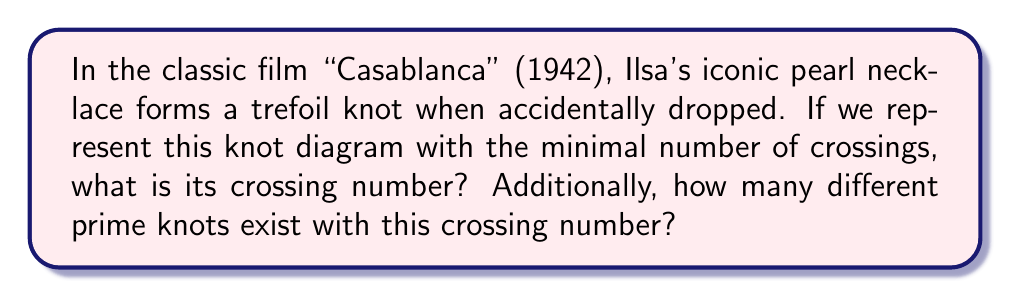What is the answer to this math problem? Let's approach this step-by-step:

1) The trefoil knot is one of the simplest non-trivial knots in knot theory.

2) To determine its crossing number, we need to consider its minimal diagram:

   [asy]
   import geometry;
   
   path p = (0,0){dir(60)}..{dir(-60)}(1,0){dir(120)}..{dir(0)}(2,0){dir(-120)}..{dir(180)}cycle;
   draw(p, linewidth(1));
   
   dot((0.33,0.2));
   dot((1,0.58));
   dot((1.67,0.2));
   [/asy]

3) As we can see from the diagram, the minimal representation of the trefoil knot has exactly 3 crossings.

4) The crossing number of a knot is defined as the minimum number of crossings in any diagram of the knot. Therefore, the crossing number of the trefoil knot is 3.

5) Now, for the second part of the question, we need to consider how many different prime knots exist with a crossing number of 3.

6) In knot theory, it's known that there is only one prime knot with a crossing number of 3, which is the trefoil knot itself.

7) Prime knots with crossing numbers:
   - 0 crossings: The unknot (not considered prime)
   - 1 crossing: None
   - 2 crossings: None
   - 3 crossings: The trefoil knot

Therefore, there is only 1 prime knot with a crossing number of 3.
Answer: Crossing number: 3, Number of prime knots: 1 